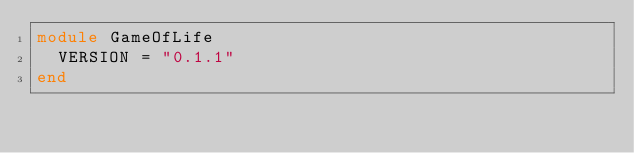Convert code to text. <code><loc_0><loc_0><loc_500><loc_500><_Ruby_>module GameOfLife
  VERSION = "0.1.1"
end
</code> 